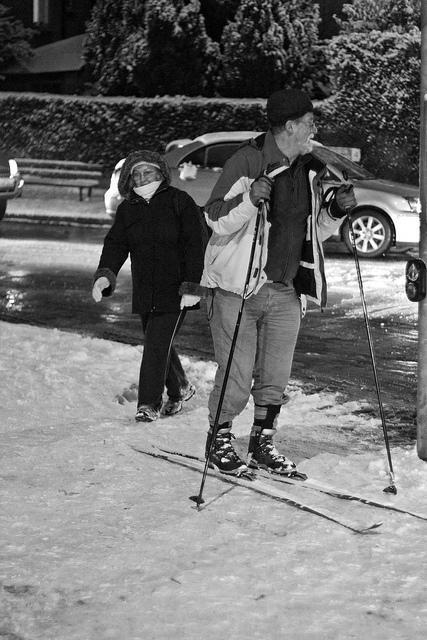How many people are wearing skiing gear in this photo?
Give a very brief answer. 1. How many people can be seen?
Give a very brief answer. 2. 